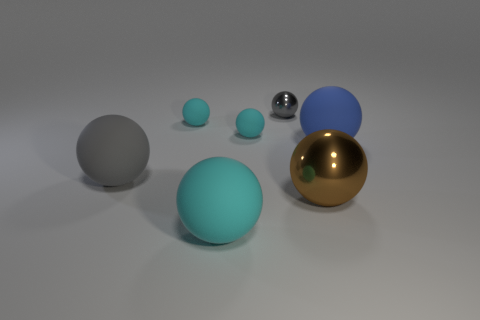Subtract all big metal spheres. How many spheres are left? 6 Subtract all brown blocks. How many gray spheres are left? 2 Subtract all cyan spheres. How many spheres are left? 4 Add 2 small cyan rubber spheres. How many objects exist? 9 Subtract all gray balls. Subtract all cyan cylinders. How many balls are left? 5 Subtract 0 gray blocks. How many objects are left? 7 Subtract all big blue matte balls. Subtract all large blue rubber spheres. How many objects are left? 5 Add 3 small cyan rubber balls. How many small cyan rubber balls are left? 5 Add 2 large purple metal blocks. How many large purple metal blocks exist? 2 